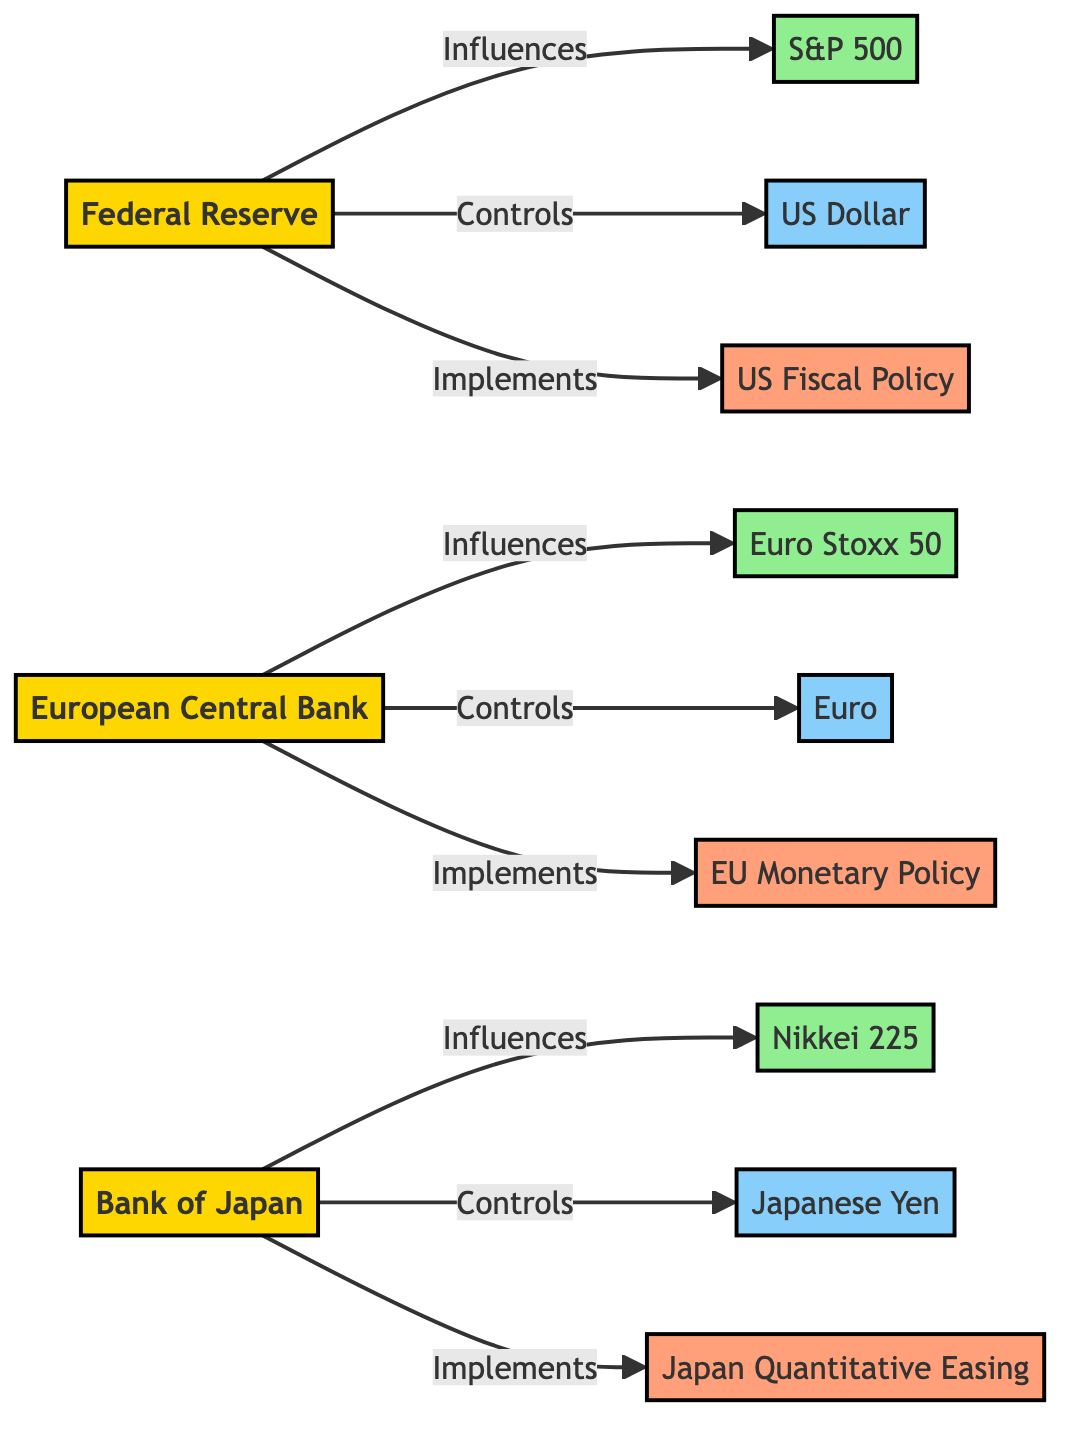What are the total number of nodes in the diagram? The diagram lists 12 nodes: 3 institutions, 3 market indexes, 3 currencies, and 3 policies. Counting all these distinct entities gives a total of 12 nodes.
Answer: 12 Which policy does the Federal Reserve implement? In the diagram, there is a clear connection showing that the Federal Reserve implements the US Fiscal Policy. Therefore, the answer is based on the relationship depicted between these two entities.
Answer: US Fiscal Policy How many influences are shown in the diagram? By examining all the edges representing the "Influences" relationship, we can see there are three relationships where institutions influence the respective market indexes: Federal Reserve to S&P 500, European Central Bank to Euro Stoxx 50, and Bank of Japan to Nikkei 225. The count of these relationships is three.
Answer: 3 Which currency is controlled by the European Central Bank? The diagram indicates that the European Central Bank controls the Euro, so this connection clearly defines the specific currency related to that institution.
Answer: Euro What does the Bank of Japan implement? Upon review, the Bank of Japan is linked through a relationship labeled "Implements" to Japan Quantitative Easing within the diagram. This clearly indicates which specific policy the Bank of Japan is responsible for implementing.
Answer: Japan Quantitative Easing Which market index is influenced by the Bank of Japan? The diagram shows that the Bank of Japan influences the Nikkei 225 index. This direct relationship clarifies that the Nikkei 225 is the specific market index that the Bank of Japan affects.
Answer: Nikkei 225 How many edges represent currency controls in this diagram? There are three distinct edges in the diagram that illustrate relationships where institutions control currencies. These are: Federal Reserve controls US Dollar, European Central Bank controls Euro, and Bank of Japan controls Japanese Yen. Summing these gives three edges specifically related to currency controls.
Answer: 3 Which institution influences the highest number of market indexes? Upon analyzing the diagram, the Federal Reserve influences only one market index (S&P 500), the European Central Bank also influences one (Euro Stoxx 50), and the Bank of Japan influences one (Nikkei 225). Therefore, all institutions influence the same number of market indexes, which is one each.
Answer: 1 Which institution is responsible for controlling the USD? According to the connections shown in the diagram, the Federal Reserve is indicated as the institution that controls the US Dollar. This relationship is distinctly marked, pointing to a single entity responsible for this currency.
Answer: Federal Reserve 